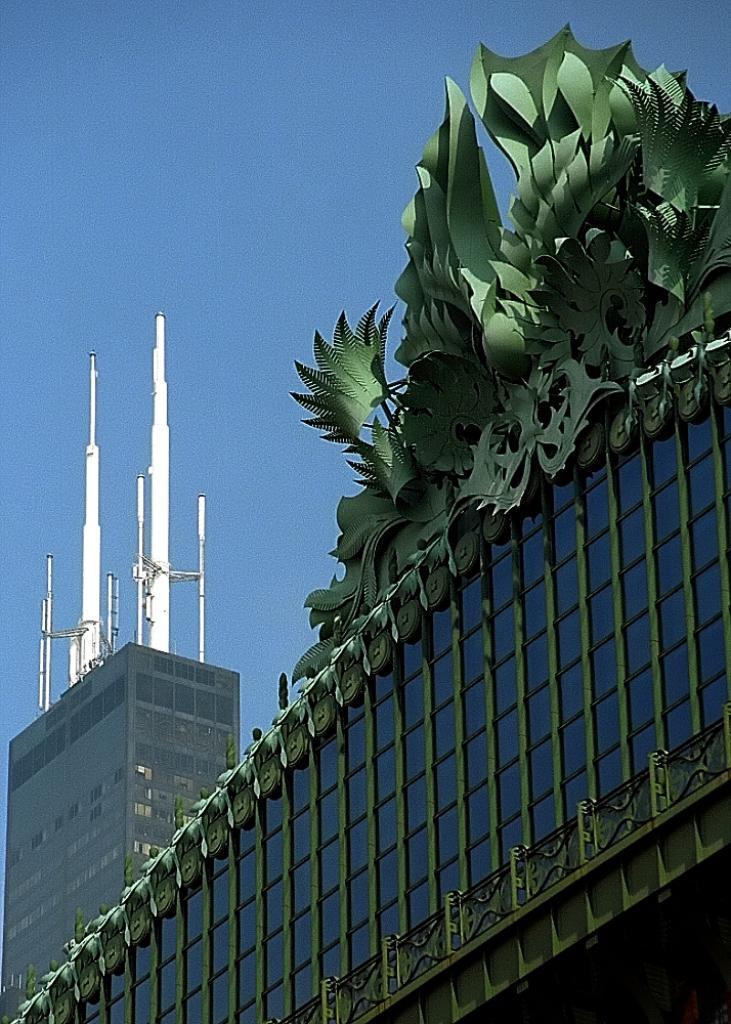Please provide a concise description of this image. This picture is clicked outside. In the foreground we can see the buildings and white color metal stands. On the right corner there is a green color object on the top of the building. In the background there is a sky. 